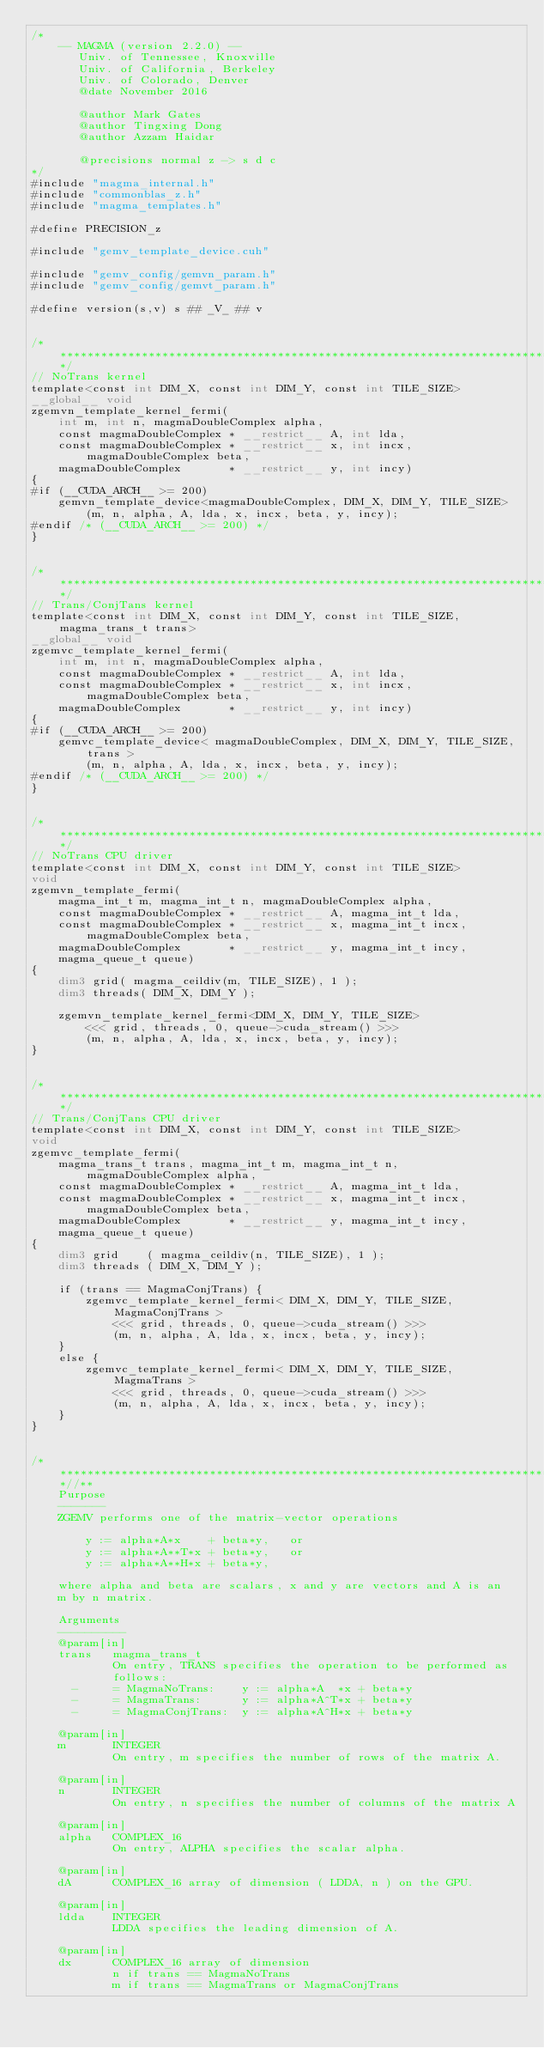Convert code to text. <code><loc_0><loc_0><loc_500><loc_500><_Cuda_>/*
    -- MAGMA (version 2.2.0) --
       Univ. of Tennessee, Knoxville
       Univ. of California, Berkeley
       Univ. of Colorado, Denver
       @date November 2016
       
       @author Mark Gates
       @author Tingxing Dong
       @author Azzam Haidar

       @precisions normal z -> s d c
*/
#include "magma_internal.h"
#include "commonblas_z.h"
#include "magma_templates.h"

#define PRECISION_z

#include "gemv_template_device.cuh"

#include "gemv_config/gemvn_param.h"
#include "gemv_config/gemvt_param.h"

#define version(s,v) s ## _V_ ## v


/******************************************************************************/
// NoTrans kernel
template<const int DIM_X, const int DIM_Y, const int TILE_SIZE>
__global__ void
zgemvn_template_kernel_fermi(
    int m, int n, magmaDoubleComplex alpha,
    const magmaDoubleComplex * __restrict__ A, int lda,
    const magmaDoubleComplex * __restrict__ x, int incx, magmaDoubleComplex beta,
    magmaDoubleComplex       * __restrict__ y, int incy)
{
#if (__CUDA_ARCH__ >= 200)
    gemvn_template_device<magmaDoubleComplex, DIM_X, DIM_Y, TILE_SIZE>
        (m, n, alpha, A, lda, x, incx, beta, y, incy);
#endif /* (__CUDA_ARCH__ >= 200) */
}


/******************************************************************************/
// Trans/ConjTans kernel
template<const int DIM_X, const int DIM_Y, const int TILE_SIZE, magma_trans_t trans>
__global__ void
zgemvc_template_kernel_fermi(
    int m, int n, magmaDoubleComplex alpha,
    const magmaDoubleComplex * __restrict__ A, int lda,
    const magmaDoubleComplex * __restrict__ x, int incx, magmaDoubleComplex beta,
    magmaDoubleComplex       * __restrict__ y, int incy)
{
#if (__CUDA_ARCH__ >= 200)
    gemvc_template_device< magmaDoubleComplex, DIM_X, DIM_Y, TILE_SIZE, trans >
        (m, n, alpha, A, lda, x, incx, beta, y, incy);
#endif /* (__CUDA_ARCH__ >= 200) */
}


/******************************************************************************/
// NoTrans CPU driver
template<const int DIM_X, const int DIM_Y, const int TILE_SIZE>
void
zgemvn_template_fermi(
    magma_int_t m, magma_int_t n, magmaDoubleComplex alpha,
    const magmaDoubleComplex * __restrict__ A, magma_int_t lda,
    const magmaDoubleComplex * __restrict__ x, magma_int_t incx, magmaDoubleComplex beta,
    magmaDoubleComplex       * __restrict__ y, magma_int_t incy,
    magma_queue_t queue)
{
    dim3 grid( magma_ceildiv(m, TILE_SIZE), 1 );
    dim3 threads( DIM_X, DIM_Y );

    zgemvn_template_kernel_fermi<DIM_X, DIM_Y, TILE_SIZE>
        <<< grid, threads, 0, queue->cuda_stream() >>>
        (m, n, alpha, A, lda, x, incx, beta, y, incy);
}


/******************************************************************************/
// Trans/ConjTans CPU driver
template<const int DIM_X, const int DIM_Y, const int TILE_SIZE>
void
zgemvc_template_fermi(
    magma_trans_t trans, magma_int_t m, magma_int_t n, magmaDoubleComplex alpha,
    const magmaDoubleComplex * __restrict__ A, magma_int_t lda,
    const magmaDoubleComplex * __restrict__ x, magma_int_t incx, magmaDoubleComplex beta,
    magmaDoubleComplex       * __restrict__ y, magma_int_t incy,
    magma_queue_t queue)
{
    dim3 grid    ( magma_ceildiv(n, TILE_SIZE), 1 );
    dim3 threads ( DIM_X, DIM_Y );
    
    if (trans == MagmaConjTrans) {
        zgemvc_template_kernel_fermi< DIM_X, DIM_Y, TILE_SIZE, MagmaConjTrans >
            <<< grid, threads, 0, queue->cuda_stream() >>>
            (m, n, alpha, A, lda, x, incx, beta, y, incy);
    }
    else {
        zgemvc_template_kernel_fermi< DIM_X, DIM_Y, TILE_SIZE, MagmaTrans >
            <<< grid, threads, 0, queue->cuda_stream() >>>
            (m, n, alpha, A, lda, x, incx, beta, y, incy);
    }
}


/***************************************************************************//**
    Purpose
    -------
    ZGEMV performs one of the matrix-vector operations
    
        y := alpha*A*x    + beta*y,   or
        y := alpha*A**T*x + beta*y,   or
        y := alpha*A**H*x + beta*y,
    
    where alpha and beta are scalars, x and y are vectors and A is an
    m by n matrix.

    Arguments
    ----------
    @param[in]
    trans   magma_trans_t
            On entry, TRANS specifies the operation to be performed as
            follows:
      -     = MagmaNoTrans:    y := alpha*A  *x + beta*y
      -     = MagmaTrans:      y := alpha*A^T*x + beta*y
      -     = MagmaConjTrans:  y := alpha*A^H*x + beta*y

    @param[in]
    m       INTEGER
            On entry, m specifies the number of rows of the matrix A.

    @param[in]
    n       INTEGER
            On entry, n specifies the number of columns of the matrix A
 
    @param[in]
    alpha   COMPLEX_16
            On entry, ALPHA specifies the scalar alpha.

    @param[in]
    dA      COMPLEX_16 array of dimension ( LDDA, n ) on the GPU.
   
    @param[in]
    ldda    INTEGER
            LDDA specifies the leading dimension of A.

    @param[in]
    dx      COMPLEX_16 array of dimension
            n if trans == MagmaNoTrans
            m if trans == MagmaTrans or MagmaConjTrans
     </code> 